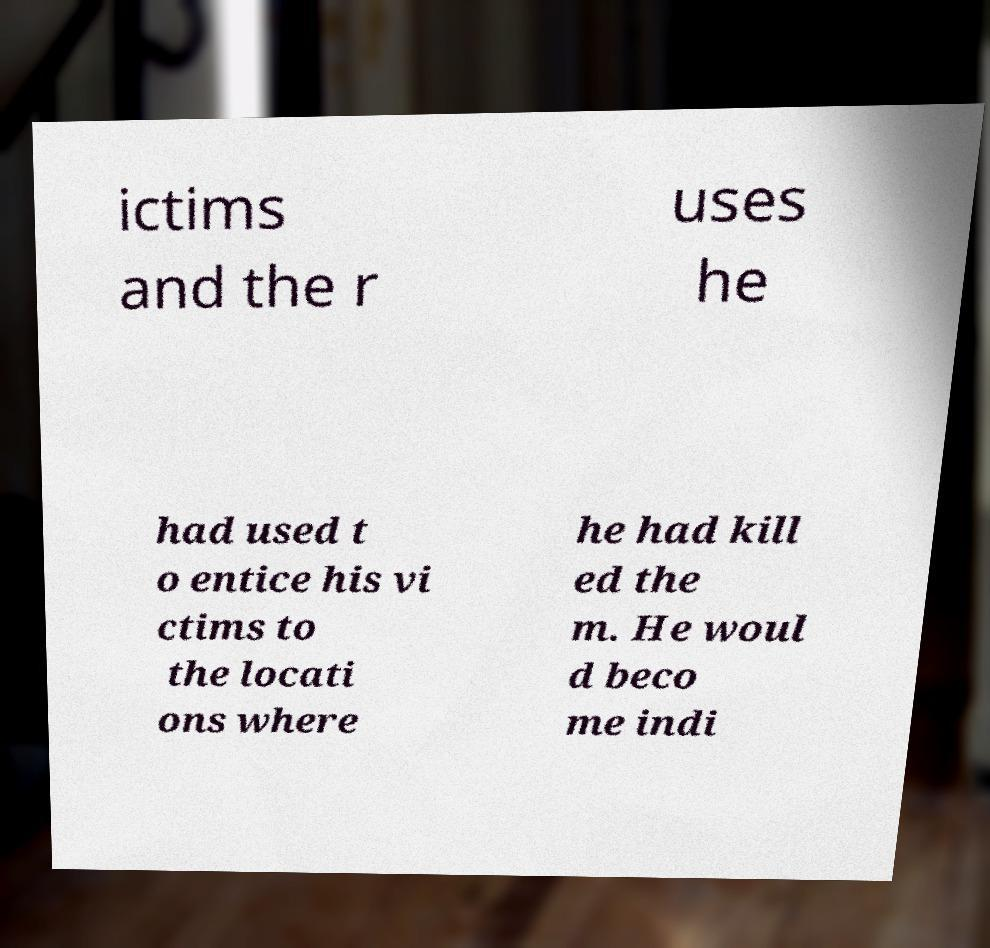Please identify and transcribe the text found in this image. ictims and the r uses he had used t o entice his vi ctims to the locati ons where he had kill ed the m. He woul d beco me indi 